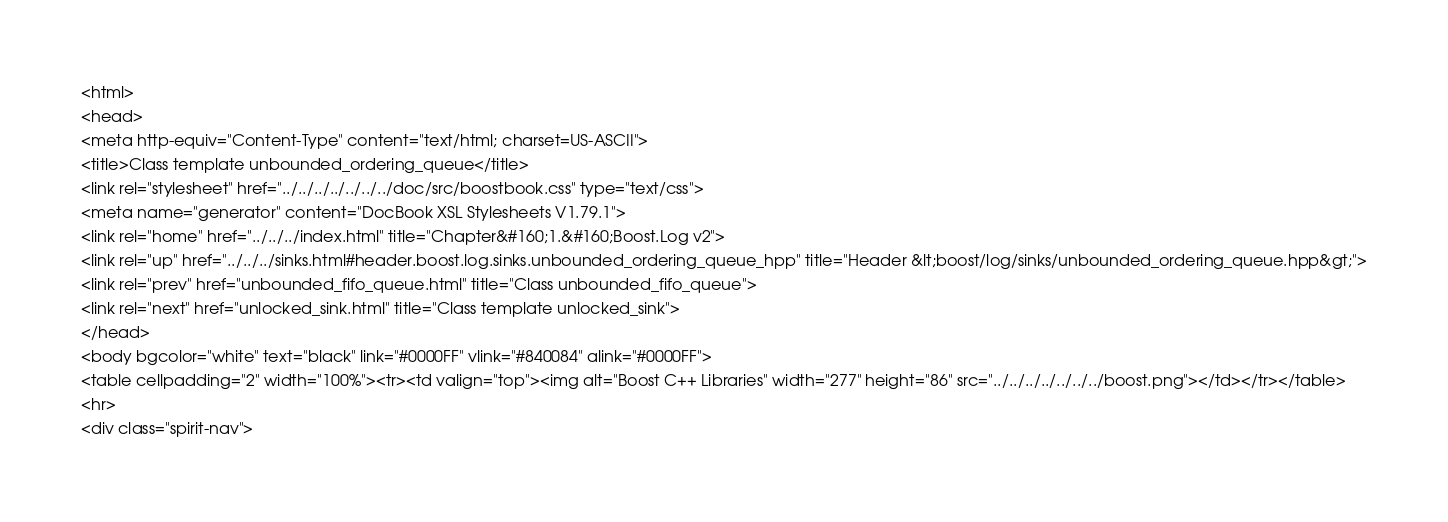<code> <loc_0><loc_0><loc_500><loc_500><_HTML_><html>
<head>
<meta http-equiv="Content-Type" content="text/html; charset=US-ASCII">
<title>Class template unbounded_ordering_queue</title>
<link rel="stylesheet" href="../../../../../../../doc/src/boostbook.css" type="text/css">
<meta name="generator" content="DocBook XSL Stylesheets V1.79.1">
<link rel="home" href="../../../index.html" title="Chapter&#160;1.&#160;Boost.Log v2">
<link rel="up" href="../../../sinks.html#header.boost.log.sinks.unbounded_ordering_queue_hpp" title="Header &lt;boost/log/sinks/unbounded_ordering_queue.hpp&gt;">
<link rel="prev" href="unbounded_fifo_queue.html" title="Class unbounded_fifo_queue">
<link rel="next" href="unlocked_sink.html" title="Class template unlocked_sink">
</head>
<body bgcolor="white" text="black" link="#0000FF" vlink="#840084" alink="#0000FF">
<table cellpadding="2" width="100%"><tr><td valign="top"><img alt="Boost C++ Libraries" width="277" height="86" src="../../../../../../../boost.png"></td></tr></table>
<hr>
<div class="spirit-nav"></code> 